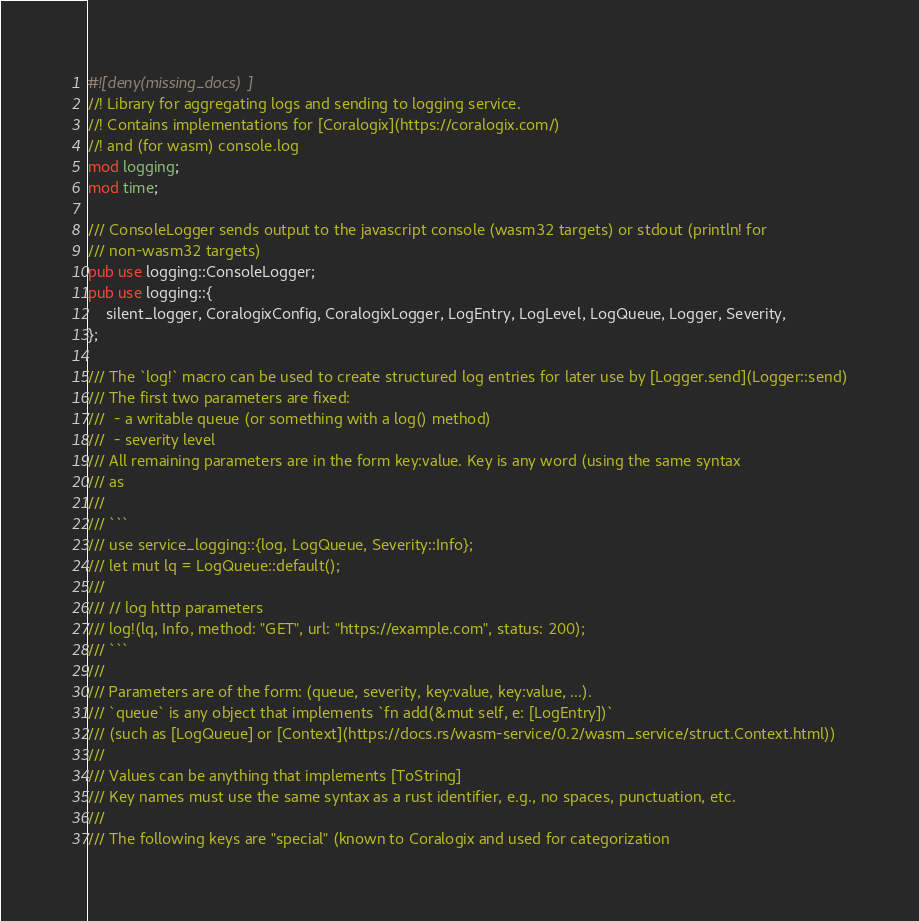<code> <loc_0><loc_0><loc_500><loc_500><_Rust_>#![deny(missing_docs)]
//! Library for aggregating logs and sending to logging service.
//! Contains implementations for [Coralogix](https://coralogix.com/)
//! and (for wasm) console.log
mod logging;
mod time;

/// ConsoleLogger sends output to the javascript console (wasm32 targets) or stdout (println! for
/// non-wasm32 targets)
pub use logging::ConsoleLogger;
pub use logging::{
    silent_logger, CoralogixConfig, CoralogixLogger, LogEntry, LogLevel, LogQueue, Logger, Severity,
};

/// The `log!` macro can be used to create structured log entries for later use by [Logger.send](Logger::send)
/// The first two parameters are fixed:
///  - a writable queue (or something with a log() method)
///  - severity level
/// All remaining parameters are in the form key:value. Key is any word (using the same syntax
/// as
///
/// ```
/// use service_logging::{log, LogQueue, Severity::Info};
/// let mut lq = LogQueue::default();
///
/// // log http parameters
/// log!(lq, Info, method: "GET", url: "https://example.com", status: 200);
/// ```
///
/// Parameters are of the form: (queue, severity, key:value, key:value, ...).
/// `queue` is any object that implements `fn add(&mut self, e: [LogEntry])`
/// (such as [LogQueue] or [Context](https://docs.rs/wasm-service/0.2/wasm_service/struct.Context.html))
///
/// Values can be anything that implements [ToString]
/// Key names must use the same syntax as a rust identifier, e.g., no spaces, punctuation, etc.
///
/// The following keys are "special" (known to Coralogix and used for categorization</code> 